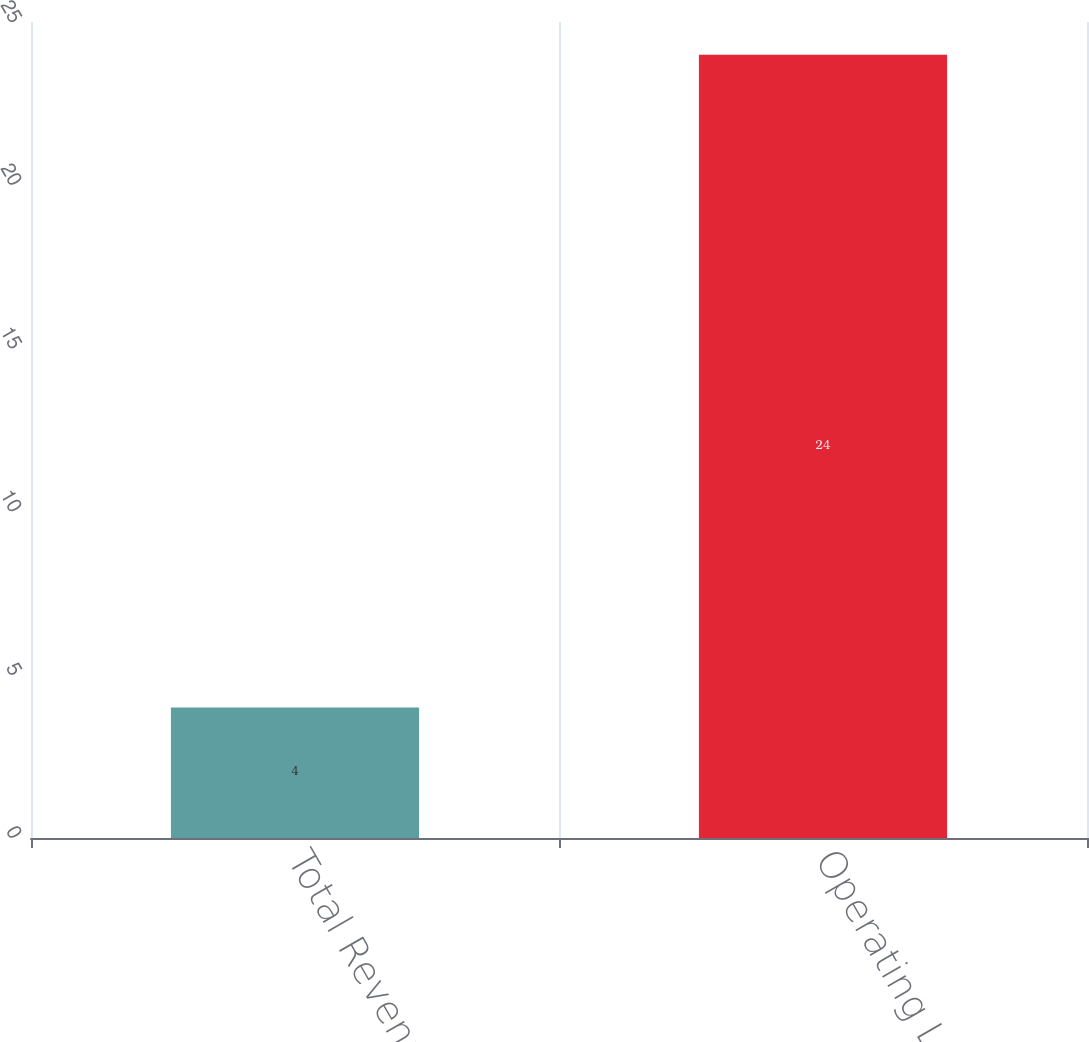Convert chart to OTSL. <chart><loc_0><loc_0><loc_500><loc_500><bar_chart><fcel>Total Revenues<fcel>Operating Loss<nl><fcel>4<fcel>24<nl></chart> 